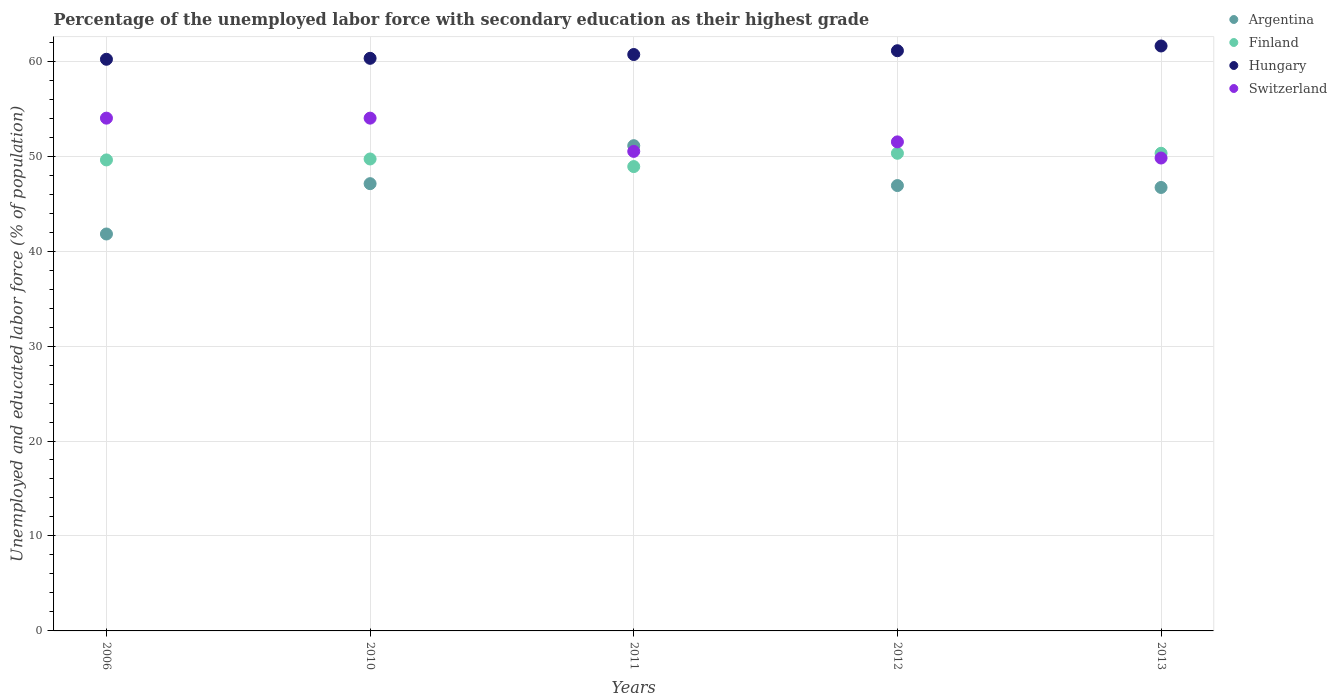What is the percentage of the unemployed labor force with secondary education in Argentina in 2012?
Provide a short and direct response. 46.9. Across all years, what is the minimum percentage of the unemployed labor force with secondary education in Switzerland?
Your answer should be compact. 49.8. In which year was the percentage of the unemployed labor force with secondary education in Switzerland maximum?
Ensure brevity in your answer.  2006. What is the total percentage of the unemployed labor force with secondary education in Finland in the graph?
Give a very brief answer. 248.8. What is the difference between the percentage of the unemployed labor force with secondary education in Hungary in 2006 and that in 2012?
Ensure brevity in your answer.  -0.9. What is the difference between the percentage of the unemployed labor force with secondary education in Argentina in 2013 and the percentage of the unemployed labor force with secondary education in Switzerland in 2012?
Keep it short and to the point. -4.8. What is the average percentage of the unemployed labor force with secondary education in Finland per year?
Keep it short and to the point. 49.76. In the year 2012, what is the difference between the percentage of the unemployed labor force with secondary education in Hungary and percentage of the unemployed labor force with secondary education in Finland?
Give a very brief answer. 10.8. Is the percentage of the unemployed labor force with secondary education in Finland in 2006 less than that in 2013?
Provide a succinct answer. Yes. Is the difference between the percentage of the unemployed labor force with secondary education in Hungary in 2006 and 2012 greater than the difference between the percentage of the unemployed labor force with secondary education in Finland in 2006 and 2012?
Offer a terse response. No. What is the difference between the highest and the lowest percentage of the unemployed labor force with secondary education in Hungary?
Keep it short and to the point. 1.4. Is the sum of the percentage of the unemployed labor force with secondary education in Argentina in 2010 and 2011 greater than the maximum percentage of the unemployed labor force with secondary education in Finland across all years?
Provide a short and direct response. Yes. Is it the case that in every year, the sum of the percentage of the unemployed labor force with secondary education in Argentina and percentage of the unemployed labor force with secondary education in Switzerland  is greater than the sum of percentage of the unemployed labor force with secondary education in Hungary and percentage of the unemployed labor force with secondary education in Finland?
Provide a succinct answer. No. Is it the case that in every year, the sum of the percentage of the unemployed labor force with secondary education in Hungary and percentage of the unemployed labor force with secondary education in Switzerland  is greater than the percentage of the unemployed labor force with secondary education in Finland?
Keep it short and to the point. Yes. Is the percentage of the unemployed labor force with secondary education in Finland strictly less than the percentage of the unemployed labor force with secondary education in Switzerland over the years?
Your answer should be very brief. No. How many years are there in the graph?
Offer a very short reply. 5. Are the values on the major ticks of Y-axis written in scientific E-notation?
Provide a succinct answer. No. Does the graph contain any zero values?
Keep it short and to the point. No. Does the graph contain grids?
Give a very brief answer. Yes. Where does the legend appear in the graph?
Offer a very short reply. Top right. How many legend labels are there?
Your answer should be very brief. 4. What is the title of the graph?
Offer a very short reply. Percentage of the unemployed labor force with secondary education as their highest grade. Does "Gabon" appear as one of the legend labels in the graph?
Your response must be concise. No. What is the label or title of the Y-axis?
Give a very brief answer. Unemployed and educated labor force (% of population). What is the Unemployed and educated labor force (% of population) in Argentina in 2006?
Offer a terse response. 41.8. What is the Unemployed and educated labor force (% of population) of Finland in 2006?
Offer a very short reply. 49.6. What is the Unemployed and educated labor force (% of population) in Hungary in 2006?
Your answer should be very brief. 60.2. What is the Unemployed and educated labor force (% of population) in Argentina in 2010?
Your response must be concise. 47.1. What is the Unemployed and educated labor force (% of population) in Finland in 2010?
Your answer should be compact. 49.7. What is the Unemployed and educated labor force (% of population) of Hungary in 2010?
Offer a terse response. 60.3. What is the Unemployed and educated labor force (% of population) of Switzerland in 2010?
Your answer should be compact. 54. What is the Unemployed and educated labor force (% of population) in Argentina in 2011?
Offer a very short reply. 51.1. What is the Unemployed and educated labor force (% of population) of Finland in 2011?
Provide a succinct answer. 48.9. What is the Unemployed and educated labor force (% of population) in Hungary in 2011?
Offer a very short reply. 60.7. What is the Unemployed and educated labor force (% of population) of Switzerland in 2011?
Your answer should be very brief. 50.5. What is the Unemployed and educated labor force (% of population) in Argentina in 2012?
Keep it short and to the point. 46.9. What is the Unemployed and educated labor force (% of population) in Finland in 2012?
Your answer should be very brief. 50.3. What is the Unemployed and educated labor force (% of population) of Hungary in 2012?
Your answer should be compact. 61.1. What is the Unemployed and educated labor force (% of population) of Switzerland in 2012?
Provide a short and direct response. 51.5. What is the Unemployed and educated labor force (% of population) of Argentina in 2013?
Offer a terse response. 46.7. What is the Unemployed and educated labor force (% of population) in Finland in 2013?
Your answer should be very brief. 50.3. What is the Unemployed and educated labor force (% of population) in Hungary in 2013?
Your answer should be very brief. 61.6. What is the Unemployed and educated labor force (% of population) of Switzerland in 2013?
Your response must be concise. 49.8. Across all years, what is the maximum Unemployed and educated labor force (% of population) of Argentina?
Your answer should be very brief. 51.1. Across all years, what is the maximum Unemployed and educated labor force (% of population) of Finland?
Your response must be concise. 50.3. Across all years, what is the maximum Unemployed and educated labor force (% of population) in Hungary?
Provide a short and direct response. 61.6. Across all years, what is the maximum Unemployed and educated labor force (% of population) of Switzerland?
Offer a very short reply. 54. Across all years, what is the minimum Unemployed and educated labor force (% of population) in Argentina?
Give a very brief answer. 41.8. Across all years, what is the minimum Unemployed and educated labor force (% of population) in Finland?
Keep it short and to the point. 48.9. Across all years, what is the minimum Unemployed and educated labor force (% of population) of Hungary?
Give a very brief answer. 60.2. Across all years, what is the minimum Unemployed and educated labor force (% of population) of Switzerland?
Make the answer very short. 49.8. What is the total Unemployed and educated labor force (% of population) of Argentina in the graph?
Your answer should be very brief. 233.6. What is the total Unemployed and educated labor force (% of population) of Finland in the graph?
Offer a terse response. 248.8. What is the total Unemployed and educated labor force (% of population) in Hungary in the graph?
Give a very brief answer. 303.9. What is the total Unemployed and educated labor force (% of population) in Switzerland in the graph?
Give a very brief answer. 259.8. What is the difference between the Unemployed and educated labor force (% of population) of Argentina in 2006 and that in 2010?
Offer a very short reply. -5.3. What is the difference between the Unemployed and educated labor force (% of population) of Switzerland in 2006 and that in 2010?
Ensure brevity in your answer.  0. What is the difference between the Unemployed and educated labor force (% of population) of Finland in 2006 and that in 2011?
Your answer should be compact. 0.7. What is the difference between the Unemployed and educated labor force (% of population) of Argentina in 2006 and that in 2012?
Your response must be concise. -5.1. What is the difference between the Unemployed and educated labor force (% of population) of Switzerland in 2006 and that in 2012?
Provide a succinct answer. 2.5. What is the difference between the Unemployed and educated labor force (% of population) in Argentina in 2006 and that in 2013?
Your answer should be compact. -4.9. What is the difference between the Unemployed and educated labor force (% of population) in Finland in 2006 and that in 2013?
Your response must be concise. -0.7. What is the difference between the Unemployed and educated labor force (% of population) of Switzerland in 2006 and that in 2013?
Offer a very short reply. 4.2. What is the difference between the Unemployed and educated labor force (% of population) of Finland in 2010 and that in 2011?
Provide a short and direct response. 0.8. What is the difference between the Unemployed and educated labor force (% of population) in Hungary in 2010 and that in 2011?
Your answer should be compact. -0.4. What is the difference between the Unemployed and educated labor force (% of population) in Switzerland in 2010 and that in 2011?
Offer a terse response. 3.5. What is the difference between the Unemployed and educated labor force (% of population) in Argentina in 2010 and that in 2012?
Keep it short and to the point. 0.2. What is the difference between the Unemployed and educated labor force (% of population) of Hungary in 2010 and that in 2012?
Provide a short and direct response. -0.8. What is the difference between the Unemployed and educated labor force (% of population) of Switzerland in 2010 and that in 2013?
Your response must be concise. 4.2. What is the difference between the Unemployed and educated labor force (% of population) in Finland in 2011 and that in 2012?
Keep it short and to the point. -1.4. What is the difference between the Unemployed and educated labor force (% of population) in Finland in 2011 and that in 2013?
Your answer should be compact. -1.4. What is the difference between the Unemployed and educated labor force (% of population) in Hungary in 2011 and that in 2013?
Offer a very short reply. -0.9. What is the difference between the Unemployed and educated labor force (% of population) in Switzerland in 2011 and that in 2013?
Provide a short and direct response. 0.7. What is the difference between the Unemployed and educated labor force (% of population) of Argentina in 2006 and the Unemployed and educated labor force (% of population) of Finland in 2010?
Offer a very short reply. -7.9. What is the difference between the Unemployed and educated labor force (% of population) of Argentina in 2006 and the Unemployed and educated labor force (% of population) of Hungary in 2010?
Provide a short and direct response. -18.5. What is the difference between the Unemployed and educated labor force (% of population) of Finland in 2006 and the Unemployed and educated labor force (% of population) of Hungary in 2010?
Your answer should be compact. -10.7. What is the difference between the Unemployed and educated labor force (% of population) of Argentina in 2006 and the Unemployed and educated labor force (% of population) of Finland in 2011?
Your answer should be very brief. -7.1. What is the difference between the Unemployed and educated labor force (% of population) of Argentina in 2006 and the Unemployed and educated labor force (% of population) of Hungary in 2011?
Your response must be concise. -18.9. What is the difference between the Unemployed and educated labor force (% of population) in Argentina in 2006 and the Unemployed and educated labor force (% of population) in Switzerland in 2011?
Make the answer very short. -8.7. What is the difference between the Unemployed and educated labor force (% of population) in Finland in 2006 and the Unemployed and educated labor force (% of population) in Switzerland in 2011?
Offer a terse response. -0.9. What is the difference between the Unemployed and educated labor force (% of population) of Argentina in 2006 and the Unemployed and educated labor force (% of population) of Finland in 2012?
Keep it short and to the point. -8.5. What is the difference between the Unemployed and educated labor force (% of population) in Argentina in 2006 and the Unemployed and educated labor force (% of population) in Hungary in 2012?
Your answer should be compact. -19.3. What is the difference between the Unemployed and educated labor force (% of population) of Finland in 2006 and the Unemployed and educated labor force (% of population) of Hungary in 2012?
Provide a short and direct response. -11.5. What is the difference between the Unemployed and educated labor force (% of population) of Finland in 2006 and the Unemployed and educated labor force (% of population) of Switzerland in 2012?
Provide a short and direct response. -1.9. What is the difference between the Unemployed and educated labor force (% of population) of Hungary in 2006 and the Unemployed and educated labor force (% of population) of Switzerland in 2012?
Your response must be concise. 8.7. What is the difference between the Unemployed and educated labor force (% of population) in Argentina in 2006 and the Unemployed and educated labor force (% of population) in Finland in 2013?
Give a very brief answer. -8.5. What is the difference between the Unemployed and educated labor force (% of population) in Argentina in 2006 and the Unemployed and educated labor force (% of population) in Hungary in 2013?
Your answer should be compact. -19.8. What is the difference between the Unemployed and educated labor force (% of population) in Finland in 2006 and the Unemployed and educated labor force (% of population) in Hungary in 2013?
Your answer should be compact. -12. What is the difference between the Unemployed and educated labor force (% of population) in Finland in 2006 and the Unemployed and educated labor force (% of population) in Switzerland in 2013?
Offer a very short reply. -0.2. What is the difference between the Unemployed and educated labor force (% of population) in Hungary in 2006 and the Unemployed and educated labor force (% of population) in Switzerland in 2013?
Offer a terse response. 10.4. What is the difference between the Unemployed and educated labor force (% of population) in Hungary in 2010 and the Unemployed and educated labor force (% of population) in Switzerland in 2011?
Your response must be concise. 9.8. What is the difference between the Unemployed and educated labor force (% of population) in Argentina in 2010 and the Unemployed and educated labor force (% of population) in Switzerland in 2012?
Offer a terse response. -4.4. What is the difference between the Unemployed and educated labor force (% of population) of Finland in 2010 and the Unemployed and educated labor force (% of population) of Hungary in 2012?
Your answer should be very brief. -11.4. What is the difference between the Unemployed and educated labor force (% of population) in Finland in 2010 and the Unemployed and educated labor force (% of population) in Switzerland in 2012?
Your answer should be very brief. -1.8. What is the difference between the Unemployed and educated labor force (% of population) of Argentina in 2010 and the Unemployed and educated labor force (% of population) of Finland in 2013?
Offer a terse response. -3.2. What is the difference between the Unemployed and educated labor force (% of population) in Argentina in 2010 and the Unemployed and educated labor force (% of population) in Hungary in 2013?
Keep it short and to the point. -14.5. What is the difference between the Unemployed and educated labor force (% of population) of Argentina in 2010 and the Unemployed and educated labor force (% of population) of Switzerland in 2013?
Your answer should be very brief. -2.7. What is the difference between the Unemployed and educated labor force (% of population) in Finland in 2010 and the Unemployed and educated labor force (% of population) in Hungary in 2013?
Make the answer very short. -11.9. What is the difference between the Unemployed and educated labor force (% of population) of Finland in 2010 and the Unemployed and educated labor force (% of population) of Switzerland in 2013?
Offer a terse response. -0.1. What is the difference between the Unemployed and educated labor force (% of population) in Argentina in 2011 and the Unemployed and educated labor force (% of population) in Finland in 2012?
Make the answer very short. 0.8. What is the difference between the Unemployed and educated labor force (% of population) of Argentina in 2011 and the Unemployed and educated labor force (% of population) of Hungary in 2013?
Your response must be concise. -10.5. What is the difference between the Unemployed and educated labor force (% of population) in Argentina in 2011 and the Unemployed and educated labor force (% of population) in Switzerland in 2013?
Your answer should be very brief. 1.3. What is the difference between the Unemployed and educated labor force (% of population) in Argentina in 2012 and the Unemployed and educated labor force (% of population) in Hungary in 2013?
Make the answer very short. -14.7. What is the difference between the Unemployed and educated labor force (% of population) of Hungary in 2012 and the Unemployed and educated labor force (% of population) of Switzerland in 2013?
Ensure brevity in your answer.  11.3. What is the average Unemployed and educated labor force (% of population) of Argentina per year?
Make the answer very short. 46.72. What is the average Unemployed and educated labor force (% of population) in Finland per year?
Offer a very short reply. 49.76. What is the average Unemployed and educated labor force (% of population) of Hungary per year?
Offer a terse response. 60.78. What is the average Unemployed and educated labor force (% of population) in Switzerland per year?
Make the answer very short. 51.96. In the year 2006, what is the difference between the Unemployed and educated labor force (% of population) in Argentina and Unemployed and educated labor force (% of population) in Hungary?
Your answer should be very brief. -18.4. In the year 2010, what is the difference between the Unemployed and educated labor force (% of population) of Finland and Unemployed and educated labor force (% of population) of Switzerland?
Make the answer very short. -4.3. In the year 2011, what is the difference between the Unemployed and educated labor force (% of population) in Argentina and Unemployed and educated labor force (% of population) in Hungary?
Your answer should be very brief. -9.6. In the year 2011, what is the difference between the Unemployed and educated labor force (% of population) of Argentina and Unemployed and educated labor force (% of population) of Switzerland?
Provide a short and direct response. 0.6. In the year 2011, what is the difference between the Unemployed and educated labor force (% of population) in Finland and Unemployed and educated labor force (% of population) in Hungary?
Your answer should be very brief. -11.8. In the year 2012, what is the difference between the Unemployed and educated labor force (% of population) in Argentina and Unemployed and educated labor force (% of population) in Switzerland?
Provide a short and direct response. -4.6. In the year 2012, what is the difference between the Unemployed and educated labor force (% of population) of Hungary and Unemployed and educated labor force (% of population) of Switzerland?
Your answer should be compact. 9.6. In the year 2013, what is the difference between the Unemployed and educated labor force (% of population) of Argentina and Unemployed and educated labor force (% of population) of Finland?
Provide a succinct answer. -3.6. In the year 2013, what is the difference between the Unemployed and educated labor force (% of population) of Argentina and Unemployed and educated labor force (% of population) of Hungary?
Keep it short and to the point. -14.9. In the year 2013, what is the difference between the Unemployed and educated labor force (% of population) of Argentina and Unemployed and educated labor force (% of population) of Switzerland?
Provide a succinct answer. -3.1. In the year 2013, what is the difference between the Unemployed and educated labor force (% of population) of Finland and Unemployed and educated labor force (% of population) of Hungary?
Your answer should be very brief. -11.3. In the year 2013, what is the difference between the Unemployed and educated labor force (% of population) in Finland and Unemployed and educated labor force (% of population) in Switzerland?
Give a very brief answer. 0.5. In the year 2013, what is the difference between the Unemployed and educated labor force (% of population) in Hungary and Unemployed and educated labor force (% of population) in Switzerland?
Keep it short and to the point. 11.8. What is the ratio of the Unemployed and educated labor force (% of population) of Argentina in 2006 to that in 2010?
Provide a succinct answer. 0.89. What is the ratio of the Unemployed and educated labor force (% of population) of Argentina in 2006 to that in 2011?
Give a very brief answer. 0.82. What is the ratio of the Unemployed and educated labor force (% of population) in Finland in 2006 to that in 2011?
Provide a short and direct response. 1.01. What is the ratio of the Unemployed and educated labor force (% of population) in Hungary in 2006 to that in 2011?
Keep it short and to the point. 0.99. What is the ratio of the Unemployed and educated labor force (% of population) of Switzerland in 2006 to that in 2011?
Give a very brief answer. 1.07. What is the ratio of the Unemployed and educated labor force (% of population) in Argentina in 2006 to that in 2012?
Give a very brief answer. 0.89. What is the ratio of the Unemployed and educated labor force (% of population) of Finland in 2006 to that in 2012?
Make the answer very short. 0.99. What is the ratio of the Unemployed and educated labor force (% of population) of Hungary in 2006 to that in 2012?
Your response must be concise. 0.99. What is the ratio of the Unemployed and educated labor force (% of population) in Switzerland in 2006 to that in 2012?
Provide a short and direct response. 1.05. What is the ratio of the Unemployed and educated labor force (% of population) in Argentina in 2006 to that in 2013?
Your answer should be very brief. 0.9. What is the ratio of the Unemployed and educated labor force (% of population) in Finland in 2006 to that in 2013?
Your response must be concise. 0.99. What is the ratio of the Unemployed and educated labor force (% of population) in Hungary in 2006 to that in 2013?
Your response must be concise. 0.98. What is the ratio of the Unemployed and educated labor force (% of population) of Switzerland in 2006 to that in 2013?
Keep it short and to the point. 1.08. What is the ratio of the Unemployed and educated labor force (% of population) of Argentina in 2010 to that in 2011?
Keep it short and to the point. 0.92. What is the ratio of the Unemployed and educated labor force (% of population) in Finland in 2010 to that in 2011?
Make the answer very short. 1.02. What is the ratio of the Unemployed and educated labor force (% of population) of Switzerland in 2010 to that in 2011?
Offer a terse response. 1.07. What is the ratio of the Unemployed and educated labor force (% of population) in Argentina in 2010 to that in 2012?
Offer a very short reply. 1. What is the ratio of the Unemployed and educated labor force (% of population) of Hungary in 2010 to that in 2012?
Make the answer very short. 0.99. What is the ratio of the Unemployed and educated labor force (% of population) of Switzerland in 2010 to that in 2012?
Keep it short and to the point. 1.05. What is the ratio of the Unemployed and educated labor force (% of population) in Argentina in 2010 to that in 2013?
Your answer should be compact. 1.01. What is the ratio of the Unemployed and educated labor force (% of population) of Finland in 2010 to that in 2013?
Provide a succinct answer. 0.99. What is the ratio of the Unemployed and educated labor force (% of population) in Hungary in 2010 to that in 2013?
Keep it short and to the point. 0.98. What is the ratio of the Unemployed and educated labor force (% of population) in Switzerland in 2010 to that in 2013?
Your answer should be very brief. 1.08. What is the ratio of the Unemployed and educated labor force (% of population) in Argentina in 2011 to that in 2012?
Offer a very short reply. 1.09. What is the ratio of the Unemployed and educated labor force (% of population) of Finland in 2011 to that in 2012?
Your response must be concise. 0.97. What is the ratio of the Unemployed and educated labor force (% of population) in Hungary in 2011 to that in 2012?
Offer a terse response. 0.99. What is the ratio of the Unemployed and educated labor force (% of population) in Switzerland in 2011 to that in 2012?
Your answer should be compact. 0.98. What is the ratio of the Unemployed and educated labor force (% of population) in Argentina in 2011 to that in 2013?
Provide a short and direct response. 1.09. What is the ratio of the Unemployed and educated labor force (% of population) of Finland in 2011 to that in 2013?
Provide a succinct answer. 0.97. What is the ratio of the Unemployed and educated labor force (% of population) of Hungary in 2011 to that in 2013?
Keep it short and to the point. 0.99. What is the ratio of the Unemployed and educated labor force (% of population) of Switzerland in 2011 to that in 2013?
Your answer should be very brief. 1.01. What is the ratio of the Unemployed and educated labor force (% of population) of Argentina in 2012 to that in 2013?
Provide a succinct answer. 1. What is the ratio of the Unemployed and educated labor force (% of population) of Finland in 2012 to that in 2013?
Your response must be concise. 1. What is the ratio of the Unemployed and educated labor force (% of population) of Switzerland in 2012 to that in 2013?
Keep it short and to the point. 1.03. What is the difference between the highest and the second highest Unemployed and educated labor force (% of population) of Hungary?
Offer a terse response. 0.5. What is the difference between the highest and the second highest Unemployed and educated labor force (% of population) in Switzerland?
Offer a terse response. 0. What is the difference between the highest and the lowest Unemployed and educated labor force (% of population) of Argentina?
Provide a succinct answer. 9.3. What is the difference between the highest and the lowest Unemployed and educated labor force (% of population) in Switzerland?
Your answer should be very brief. 4.2. 